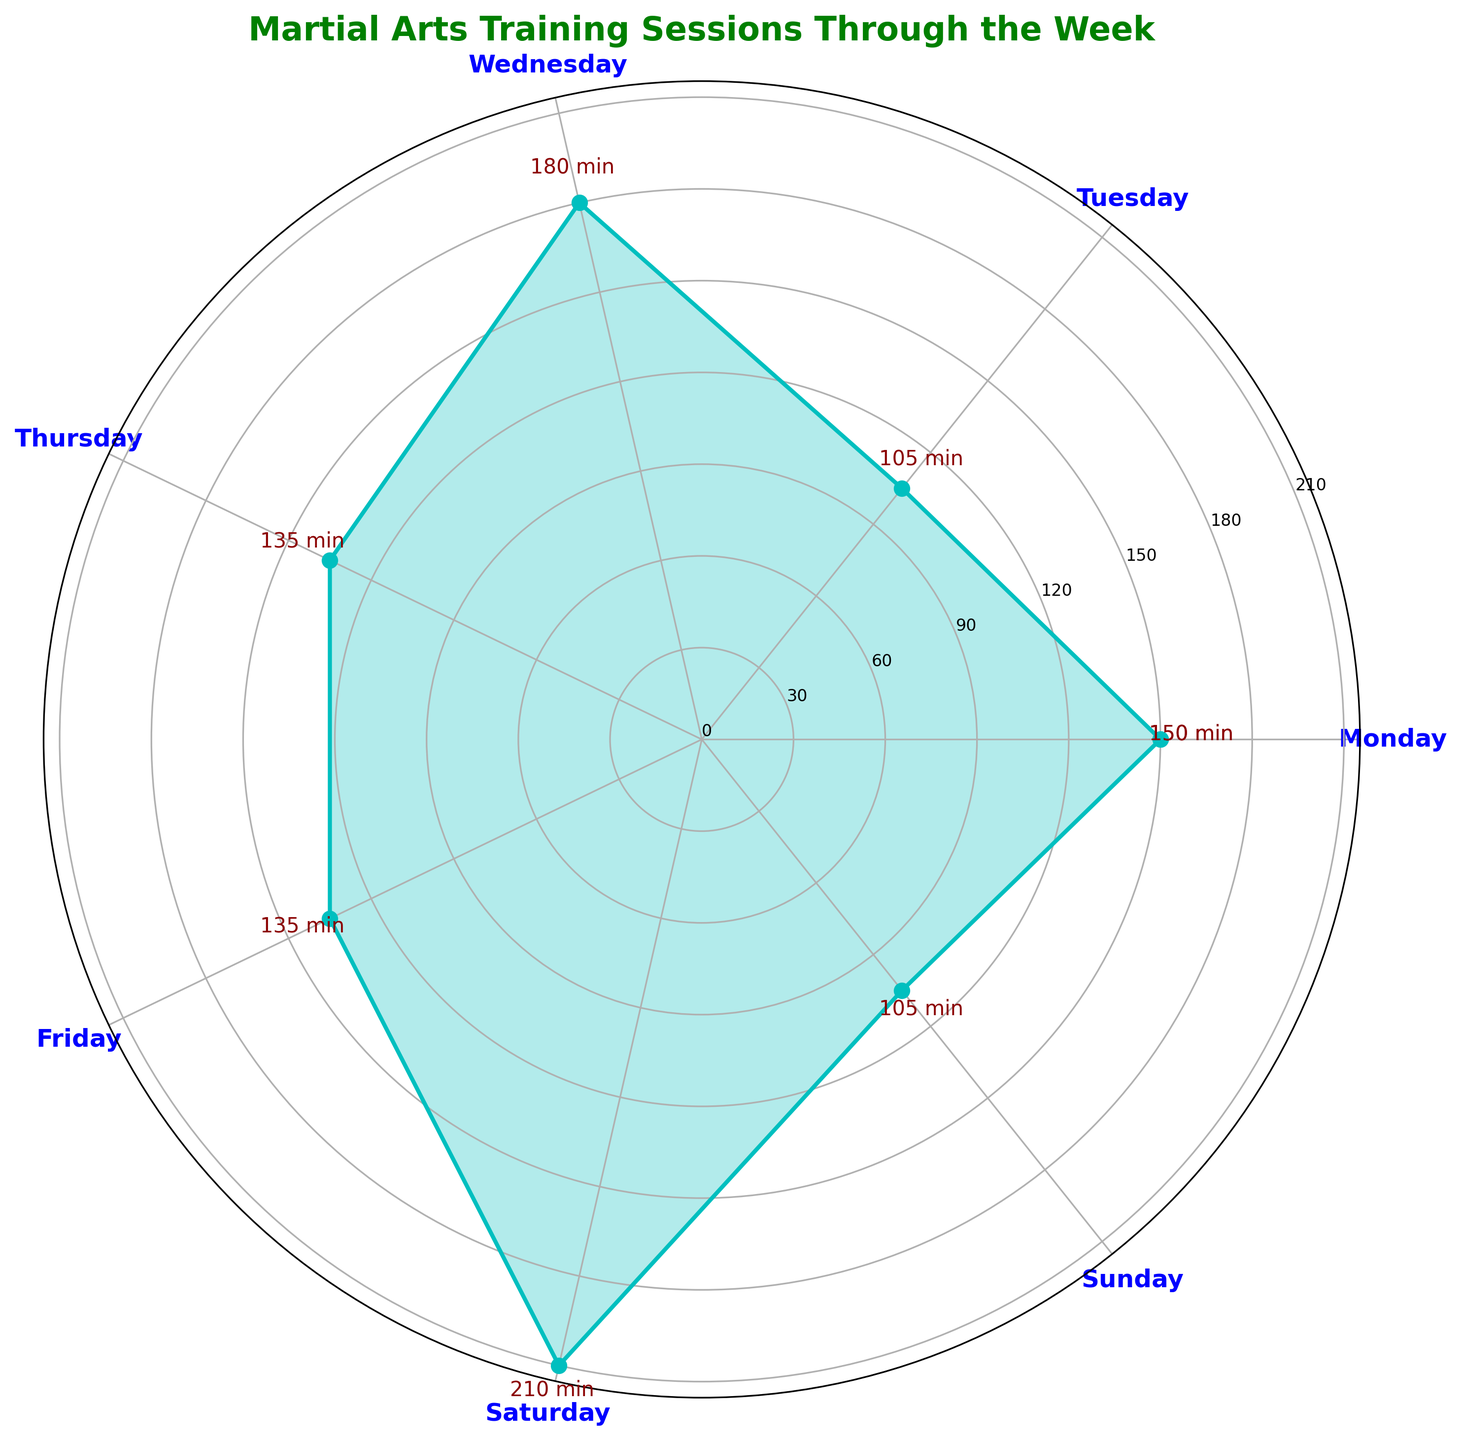What day has the highest total session duration? Look at the length of the plotted line segments in the rose chart. The longest segment indicates the highest total session duration, which is on Saturday.
Answer: Saturday Which day has the least total session duration? Identify the shortest line segment in the rose chart. The shortest segment is on Thursday.
Answer: Thursday How does the total session duration on Wednesday compare to Monday? Measure the length of the plotted line segments for Wednesday and Monday. Wednesday has a longer segment, indicating a greater session duration.
Answer: Wednesday has more What is the total session duration for the days with training sessions longer than 60 minutes? Identify the days with plotted line segments extending beyond the 60-minute mark: Wednesday, Friday, and Saturday. Sum their total session durations: 180 minutes (Wednesday), 135 minutes (Friday), and 210 minutes (Saturday). The sum is 180 + 135 + 210 = 525 minutes.
Answer: 525 minutes How does the total session duration on Friday compare to Sunday? Observe the length of the plotted line segments for Friday and Sunday. Friday has a longer segment, indicating a greater total session duration than Sunday.
Answer: Friday has more What day shows the highest frequency of training sessions? Assess the labels next to each segment. The day with the highest number of labels indicates the highest frequency, which appears to be Monday.
Answer: Monday What is the combined duration of training sessions on Tuesday and Thursday? Check the lengths of the plotted line segments for Tuesday and Thursday and sum their session durations: 105 minutes (Tuesday) + 135 minutes (Thursday) = 240 minutes.
Answer: 240 minutes How does the training session duration on Monday compare with Friday? Compare the lengths of the line segments for Monday and Friday. Monday has shorter segments overall than Friday.
Answer: Monday has less Which day has the longest single training session duration? Examine the points marked on the rose chart. The longest single session duration is visible on Wednesday with a segment extending to 120 minutes.
Answer: Wednesday (120 minutes) What is the average duration of the training sessions for the entire week? Sum all session durations: 60 + 90 + 45 + 60 + 120 + 60 + 45 + 90 + 60 + 75 + 120 + 90 + 60 + 45 = 1080 minutes. There are 14 sessions. Average duration = 1080 / 14 = 77.14 minutes.
Answer: 77.14 minutes 